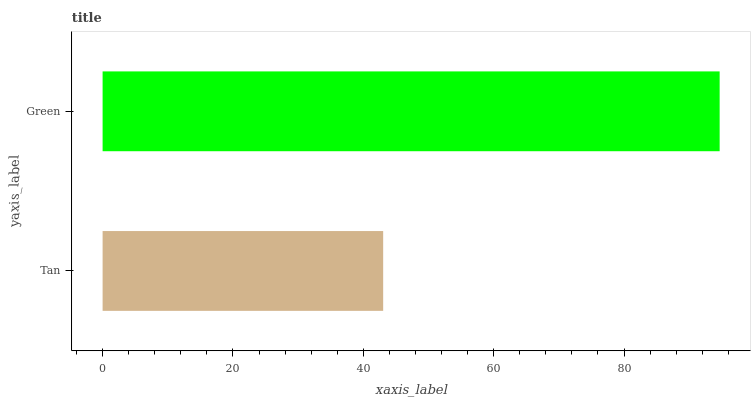Is Tan the minimum?
Answer yes or no. Yes. Is Green the maximum?
Answer yes or no. Yes. Is Green the minimum?
Answer yes or no. No. Is Green greater than Tan?
Answer yes or no. Yes. Is Tan less than Green?
Answer yes or no. Yes. Is Tan greater than Green?
Answer yes or no. No. Is Green less than Tan?
Answer yes or no. No. Is Green the high median?
Answer yes or no. Yes. Is Tan the low median?
Answer yes or no. Yes. Is Tan the high median?
Answer yes or no. No. Is Green the low median?
Answer yes or no. No. 